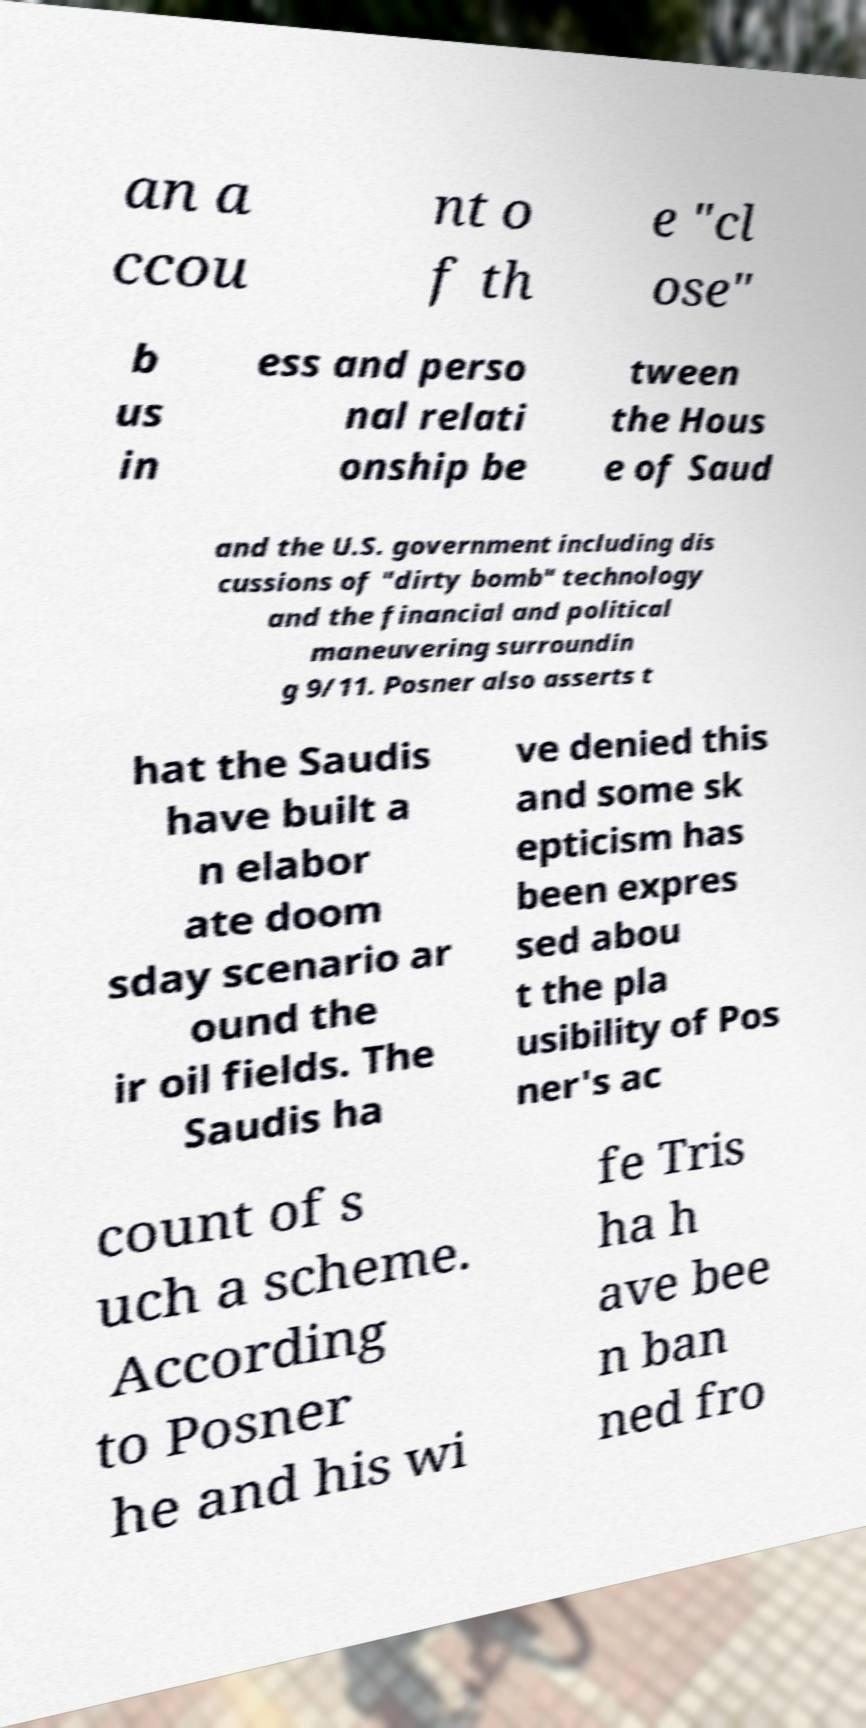What messages or text are displayed in this image? I need them in a readable, typed format. an a ccou nt o f th e "cl ose" b us in ess and perso nal relati onship be tween the Hous e of Saud and the U.S. government including dis cussions of "dirty bomb" technology and the financial and political maneuvering surroundin g 9/11. Posner also asserts t hat the Saudis have built a n elabor ate doom sday scenario ar ound the ir oil fields. The Saudis ha ve denied this and some sk epticism has been expres sed abou t the pla usibility of Pos ner's ac count of s uch a scheme. According to Posner he and his wi fe Tris ha h ave bee n ban ned fro 